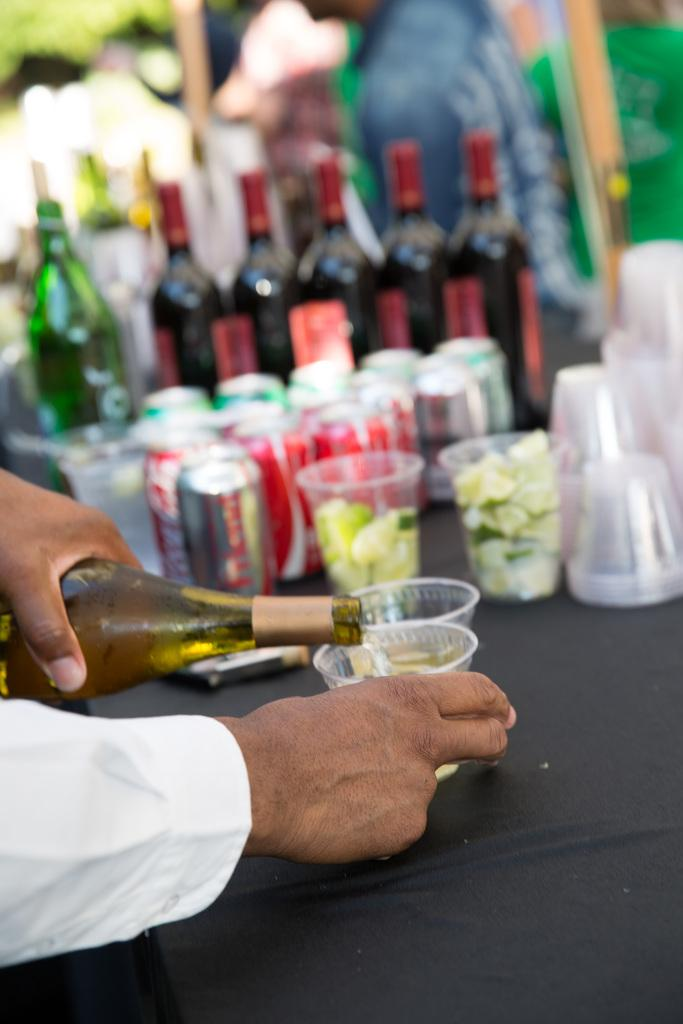<image>
Relay a brief, clear account of the picture shown. Man pouring a cup of wine in front of some Coca Cola cans. 